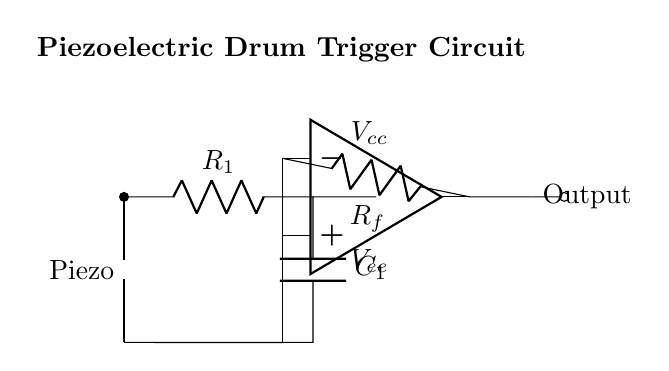What type of sensor is used in this circuit? The diagram clearly shows a piezoelectric sensor at the beginning of the circuit, indicated by the piezoelectric symbol.
Answer: Piezoelectric What is the role of the operational amplifier in this circuit? The operational amplifier amplifies the output signal from the piezoelectric sensor, which converts small electrical signals generated by the sensor into a more usable voltage level.
Answer: Amplification What are the two resistors shown in the circuit? The diagram indicates one resistor as R1, which is in parallel with a capacitor, and another as Rf, which is the feedback resistor for the operational amplifier.
Answer: R1 and Rf How is the capacitor connected in this circuit? The capacitor is connected in parallel to R1, allowing it to filter the signal by shunting high-frequency noise while passing the desired frequency through.
Answer: Parallel What type of output does this circuit generate? The output from the circuit is a signal from the op-amp, which is indicated by the signal flowing to the output node marked with an open circle.
Answer: Electronic signal 